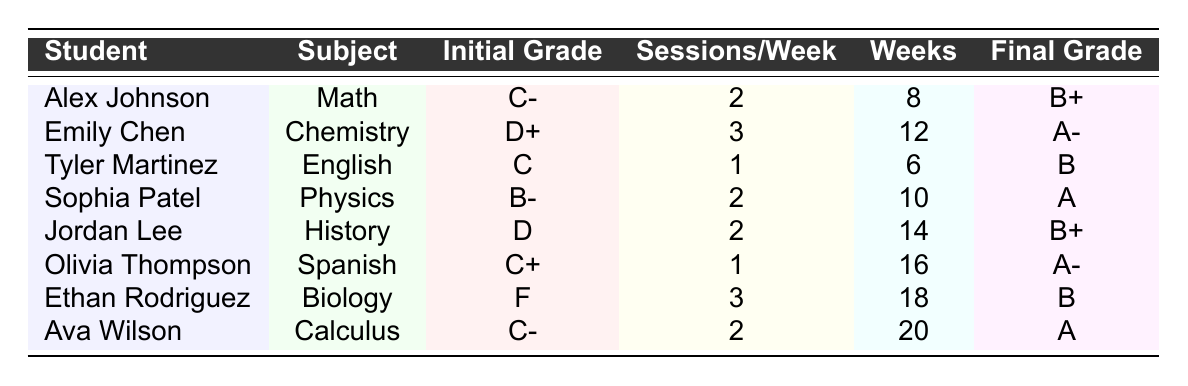What subject did Jordan Lee receive tutoring in? Jordan Lee is listed in the table, and under the "Subject" column, it specifies "History."
Answer: History How many sessions per week did Emily Chen attend? Looking at the table, under Emily Chen, the "Sessions/Week" column indicates that the number is 3.
Answer: 3 What was Ethan Rodriguez's initial grade before tutoring? Referring to the table, Ethan Rodriguez's "Initial Grade" is listed as "F."
Answer: F Which student had the highest final grade? To find the highest final grade, we look at the "Final Grade" column. The grades listed are A-, A, B+, and B; the highest is "A." Sophia Patel and Emily Chen both have this grade, but considering the data listed, Sophia is the first to achieve it.
Answer: A On average, how many sessions per week did the students attend? Adding the sessions per week: 2 + 3 + 1 + 2 + 2 + 1 + 3 + 2 = 16. There are 8 students, so the average is 16 / 8 = 2.
Answer: 2 Did any student improve from an F to a passing grade? Yes, Ethan Rodriguez started with an "F" and ended up with a "B," indicating an improvement to a passing grade.
Answer: Yes How many weeks of tutoring did Olivia Thompson receive? From the table, Olivia Thompson's "Weeks" is clearly stated as 16 weeks.
Answer: 16 What was the improvement in grades for Alex Johnson? Alex Johnson's initial grade was "C-" and his final grade was "B+." This indicates an improvement of at least two letter grades.
Answer: Two grades Which student attended the most tutoring sessions in total? Calculating the total sessions for each student by multiplying "Sessions/Week" by "Weeks": Alex (2*8=16), Emily (3*12=36), Tyler (1*6=6), Sophia (2*10=20), Jordan (2*14=28), Olivia (1*16=16), Ethan (3*18=54), Ava (2*20=40). Ethan attended the most with 54 sessions.
Answer: Ethan Rodriguez What was the final grade of the student with the second highest initial grade? Looking at the initial grades, the second highest is "B-" from Sophia Patel. Her final grade is "A." So, Sophia improved from B- to A.
Answer: A 